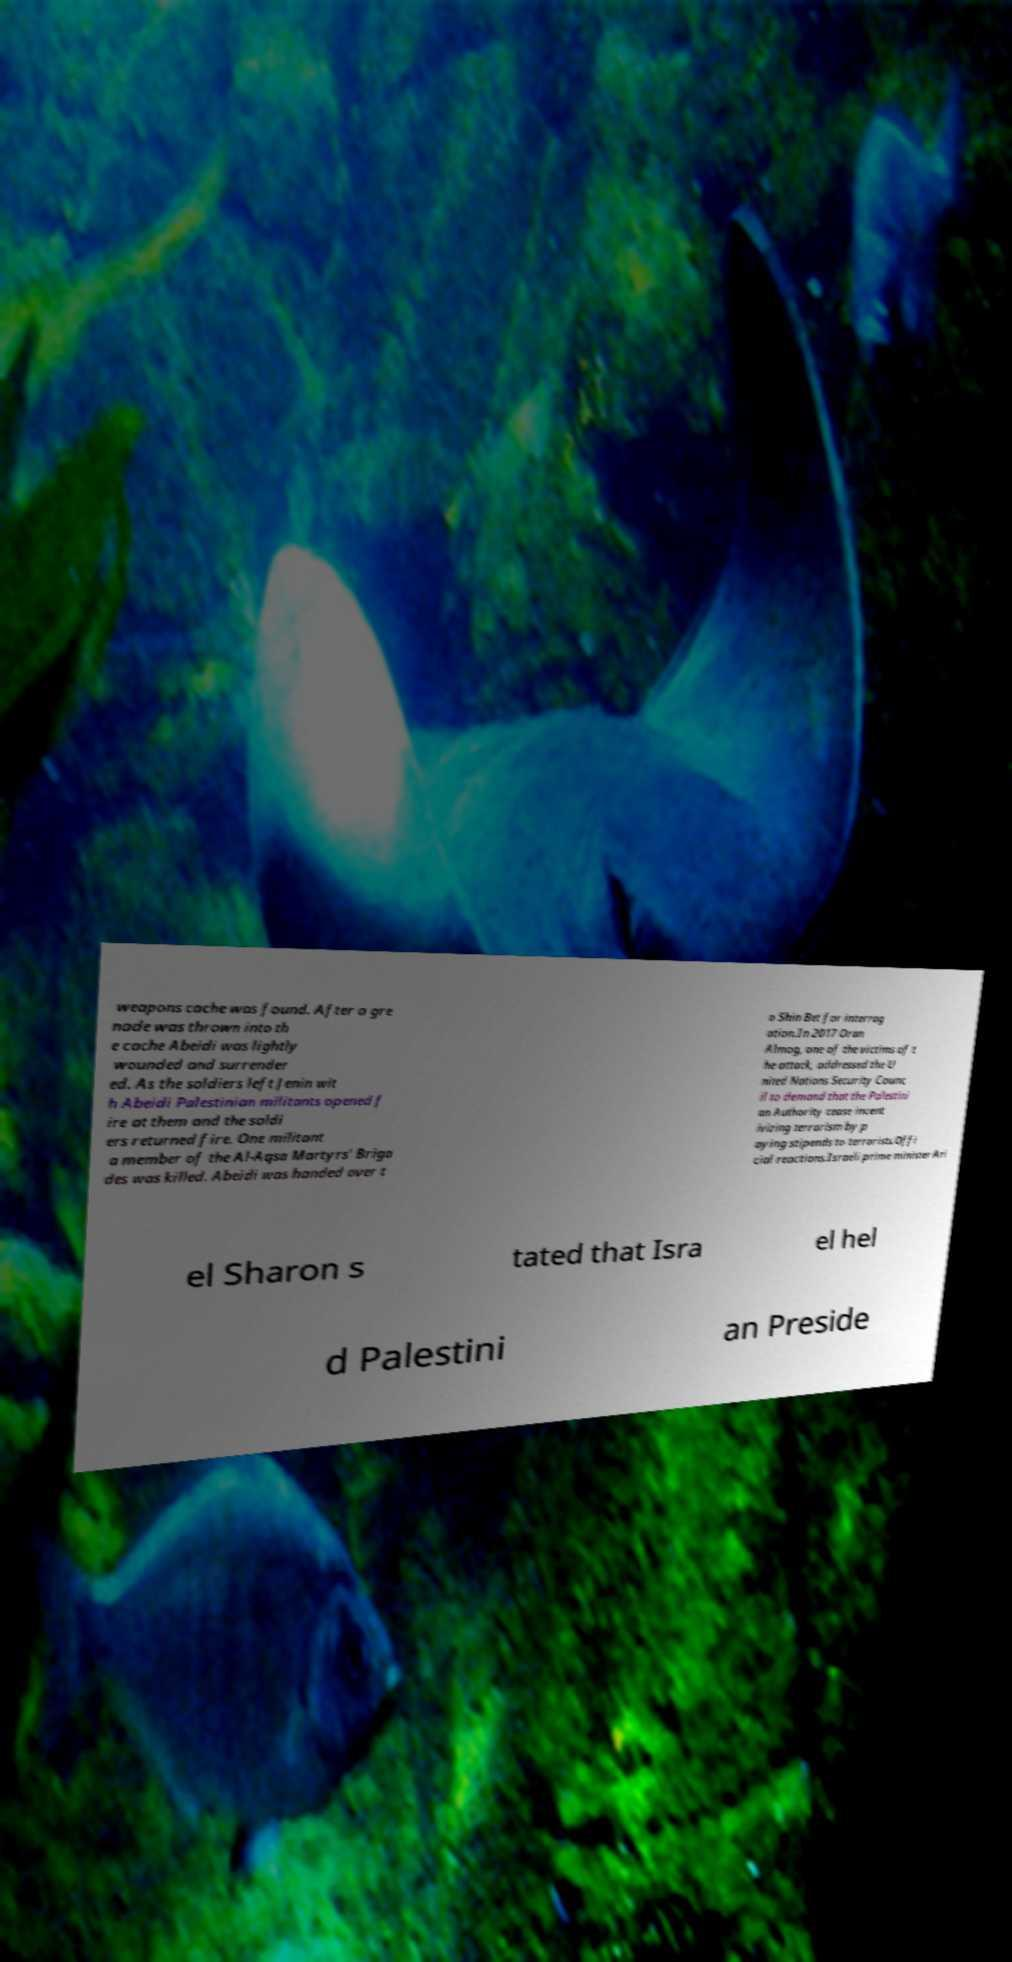Please read and relay the text visible in this image. What does it say? weapons cache was found. After a gre nade was thrown into th e cache Abeidi was lightly wounded and surrender ed. As the soldiers left Jenin wit h Abeidi Palestinian militants opened f ire at them and the soldi ers returned fire. One militant a member of the Al-Aqsa Martyrs' Briga des was killed. Abeidi was handed over t o Shin Bet for interrog ation.In 2017 Oran Almog, one of the victims of t he attack, addressed the U nited Nations Security Counc il to demand that the Palestini an Authority cease incent ivizing terrorism by p aying stipends to terrorists.Offi cial reactions.Israeli prime minister Ari el Sharon s tated that Isra el hel d Palestini an Preside 